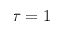<formula> <loc_0><loc_0><loc_500><loc_500>\tau = 1</formula> 